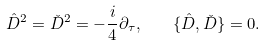Convert formula to latex. <formula><loc_0><loc_0><loc_500><loc_500>\hat { D } ^ { 2 } = \check { D } ^ { 2 } = - \frac { i } { 4 } \partial _ { \tau } , \quad \{ \hat { D } , \check { D } \} = 0 .</formula> 